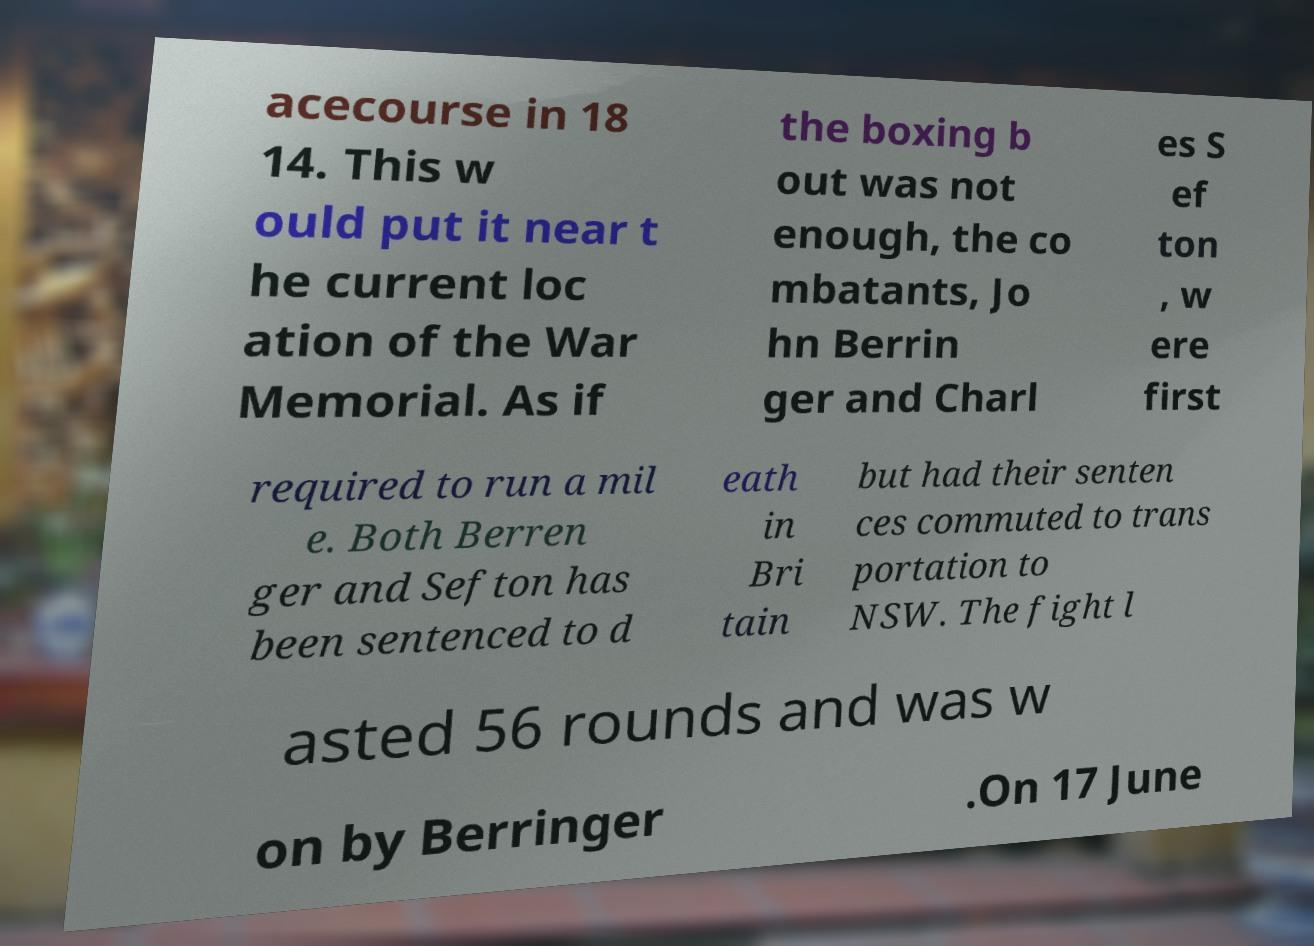Can you accurately transcribe the text from the provided image for me? acecourse in 18 14. This w ould put it near t he current loc ation of the War Memorial. As if the boxing b out was not enough, the co mbatants, Jo hn Berrin ger and Charl es S ef ton , w ere first required to run a mil e. Both Berren ger and Sefton has been sentenced to d eath in Bri tain but had their senten ces commuted to trans portation to NSW. The fight l asted 56 rounds and was w on by Berringer .On 17 June 